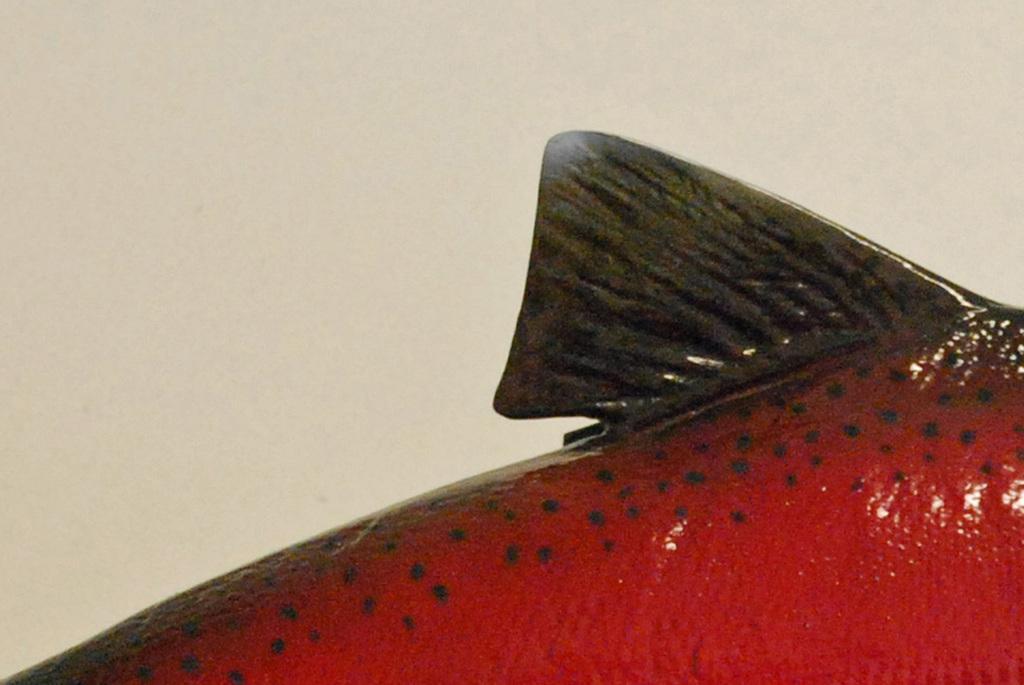Can you describe this image briefly? At the bottom we can see a red fish. At the top there is a wall. 